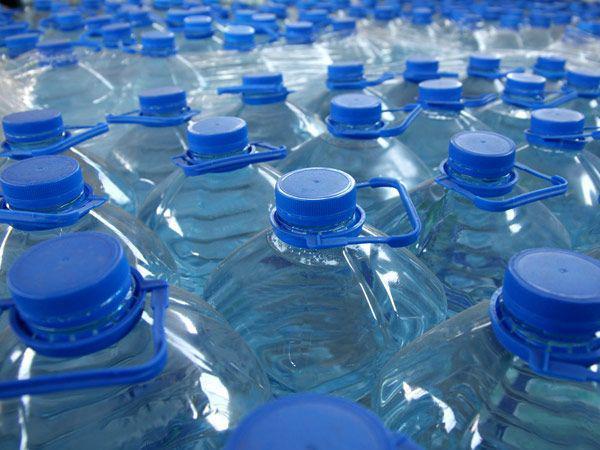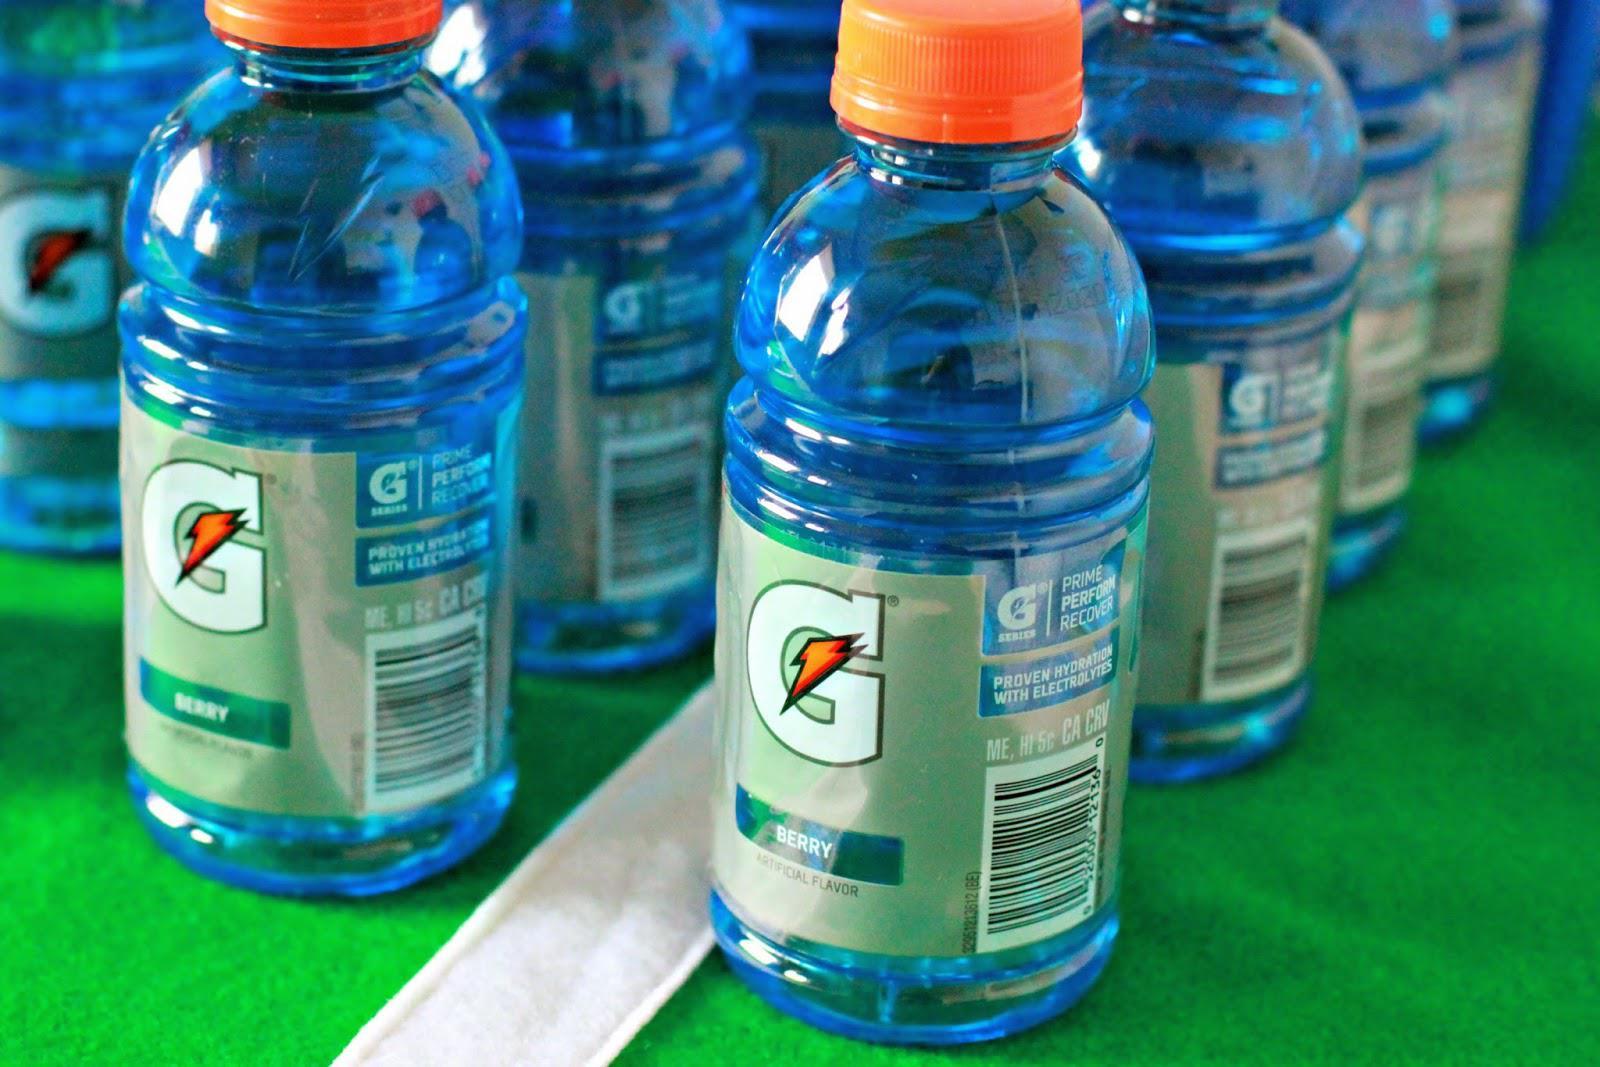The first image is the image on the left, the second image is the image on the right. Analyze the images presented: Is the assertion "An image shows bottles with orange lids." valid? Answer yes or no. Yes. 